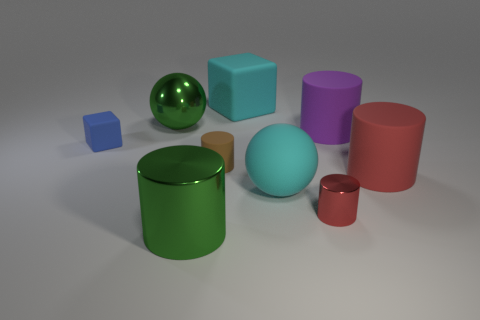Subtract all brown cylinders. How many cylinders are left? 4 Subtract all small red cylinders. How many cylinders are left? 4 Subtract 1 cylinders. How many cylinders are left? 4 Subtract all green cylinders. Subtract all green balls. How many cylinders are left? 4 Subtract all blocks. How many objects are left? 7 Subtract all large red rubber cylinders. Subtract all red metallic cylinders. How many objects are left? 7 Add 8 green objects. How many green objects are left? 10 Add 8 small red metallic objects. How many small red metallic objects exist? 9 Subtract 0 blue spheres. How many objects are left? 9 